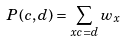Convert formula to latex. <formula><loc_0><loc_0><loc_500><loc_500>P ( c , d ) = \sum _ { x c = d } w _ { x }</formula> 